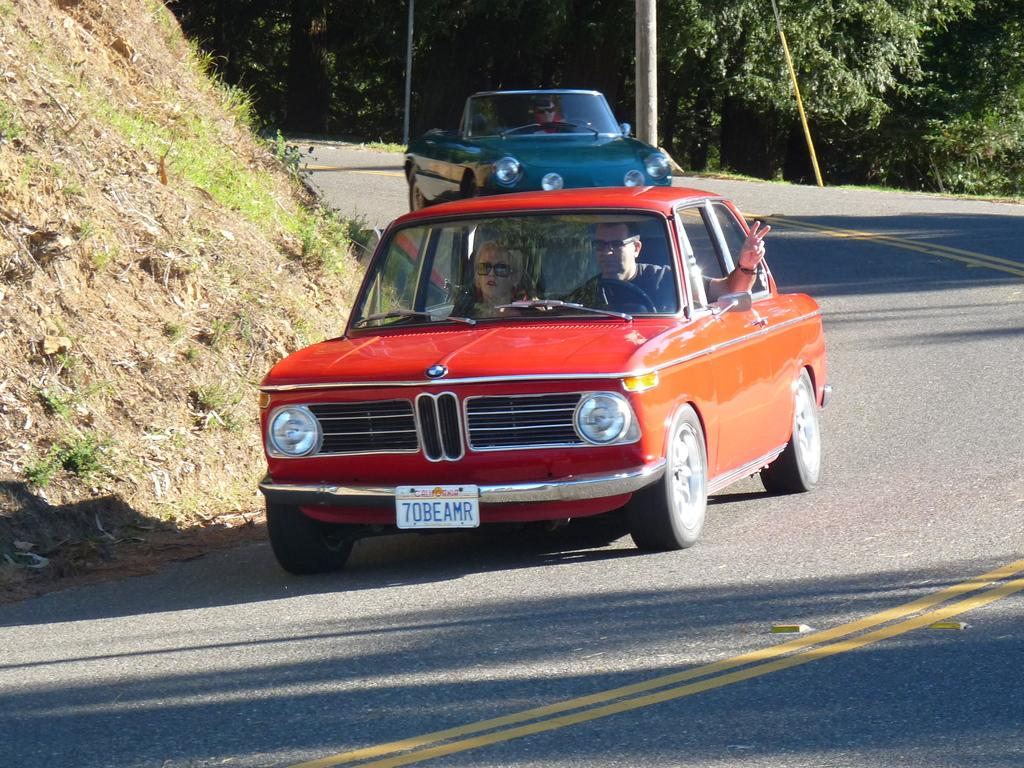How many cars can be seen traveling on the road in the image? There are two different cars traveling on the road in the image. What is visible on the left side of the road? There is a mountain on the left side of the road in the image. What type of vegetation is present on the right side of the road? There are plenty of trees on the right side of the road in the image. Where is the man storing his bike in the image? There is no man or bike present in the image. 